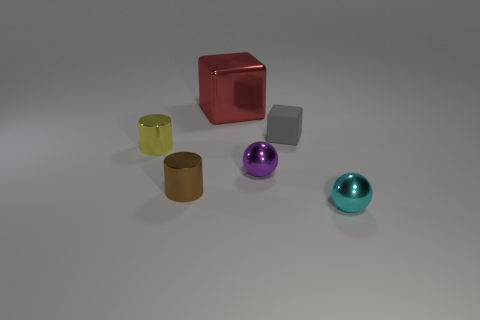What number of shiny spheres have the same color as the small rubber thing?
Offer a terse response. 0. What number of objects are to the right of the red shiny cube and to the left of the cyan metallic ball?
Provide a short and direct response. 2. What is the shape of the gray rubber thing that is the same size as the purple ball?
Provide a succinct answer. Cube. What size is the cyan metal ball?
Keep it short and to the point. Small. There is a ball that is behind the small cylinder in front of the cylinder behind the tiny brown thing; what is it made of?
Provide a succinct answer. Metal. The big block that is the same material as the small purple thing is what color?
Keep it short and to the point. Red. There is a cube right of the cube behind the tiny gray thing; what number of small purple objects are on the right side of it?
Ensure brevity in your answer.  0. Are there any other things that are the same shape as the cyan metal object?
Your answer should be very brief. Yes. How many objects are either small spheres in front of the brown cylinder or brown cubes?
Provide a succinct answer. 1. Is the color of the small metallic thing to the right of the gray rubber block the same as the large shiny object?
Provide a short and direct response. No. 